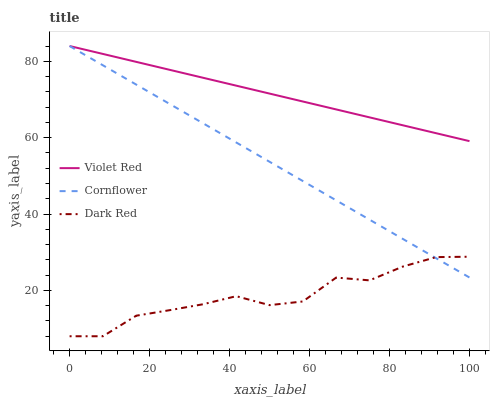Does Dark Red have the minimum area under the curve?
Answer yes or no. Yes. Does Violet Red have the maximum area under the curve?
Answer yes or no. Yes. Does Violet Red have the minimum area under the curve?
Answer yes or no. No. Does Dark Red have the maximum area under the curve?
Answer yes or no. No. Is Cornflower the smoothest?
Answer yes or no. Yes. Is Dark Red the roughest?
Answer yes or no. Yes. Is Violet Red the smoothest?
Answer yes or no. No. Is Violet Red the roughest?
Answer yes or no. No. Does Dark Red have the lowest value?
Answer yes or no. Yes. Does Violet Red have the lowest value?
Answer yes or no. No. Does Violet Red have the highest value?
Answer yes or no. Yes. Does Dark Red have the highest value?
Answer yes or no. No. Is Dark Red less than Violet Red?
Answer yes or no. Yes. Is Violet Red greater than Dark Red?
Answer yes or no. Yes. Does Cornflower intersect Violet Red?
Answer yes or no. Yes. Is Cornflower less than Violet Red?
Answer yes or no. No. Is Cornflower greater than Violet Red?
Answer yes or no. No. Does Dark Red intersect Violet Red?
Answer yes or no. No. 